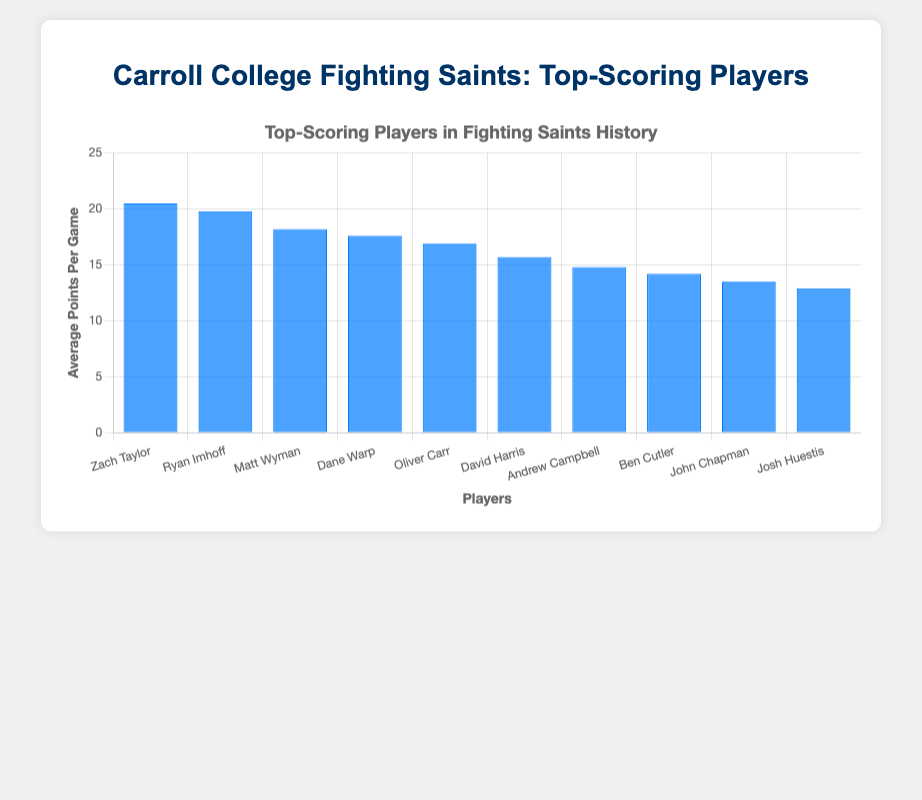Which player has the highest average points per game? The player with the highest bar represents the player with the highest average points per game. The highest bar belongs to Zach Taylor.
Answer: Zach Taylor Which player has the lowest average points per game? The player with the lowest bar represents the player with the lowest average points per game. The shortest bar belongs to Josh Huestis.
Answer: Josh Huestis How much higher is Zach Taylor's average points per game compared to Ryan Imhoff's? Zach Taylor's average points per game is 20.5 and Ryan Imhoff's is 19.8. Subtract Ryan Imhoff's average from Zach Taylor's average: 20.5 - 19.8 = 0.7.
Answer: 0.7 What is the combined average points per game of the top 3 players? The top 3 players are Zach Taylor, Ryan Imhoff, and Matt Wyman with averages of 20.5, 19.8, and 18.2, respectively. Sum these averages: 20.5 + 19.8 + 18.2 = 58.5.
Answer: 58.5 Given the highest and the lowest average points per game, what is the range? The range is the difference between the highest and the lowest average points per game. The highest is 20.5 (Zach Taylor) and the lowest is 12.9 (Josh Huestis). Calculate the difference: 20.5 - 12.9 = 7.6.
Answer: 7.6 Who has a greater average points per game, Dane Warp or Oliver Carr? Compare the heights of the bars for Dane Warp and Oliver Carr. Dane Warp's bar represents 17.6, and Oliver Carr's represents 16.9. Dane Warp's bar is higher.
Answer: Dane Warp What is the average points per game of the mid-ranked player in this chart? The mid-ranked player is the 5th player when sorted by average points per game. The players are already sorted, so Oliver Carr, who is 5th, has an average of 16.9 points per game.
Answer: 16.9 How many players have an average of more than 15 points per game? Count the number of bars with a height above the 15 points mark. Zach Taylor, Ryan Imhoff, Matt Wyman, Dane Warp, Oliver Carr, and David Harris each have averages above 15. There are 6 players.
Answer: 6 Which players have an average below 15 points per game? Identify the bars with heights below the 15 points mark. Andrew Campbell, Ben Cutler, John Chapman, and Josh Huestis each have averages below 15.
Answer: Andrew Campbell, Ben Cutler, John Chapman, Josh Huestis 